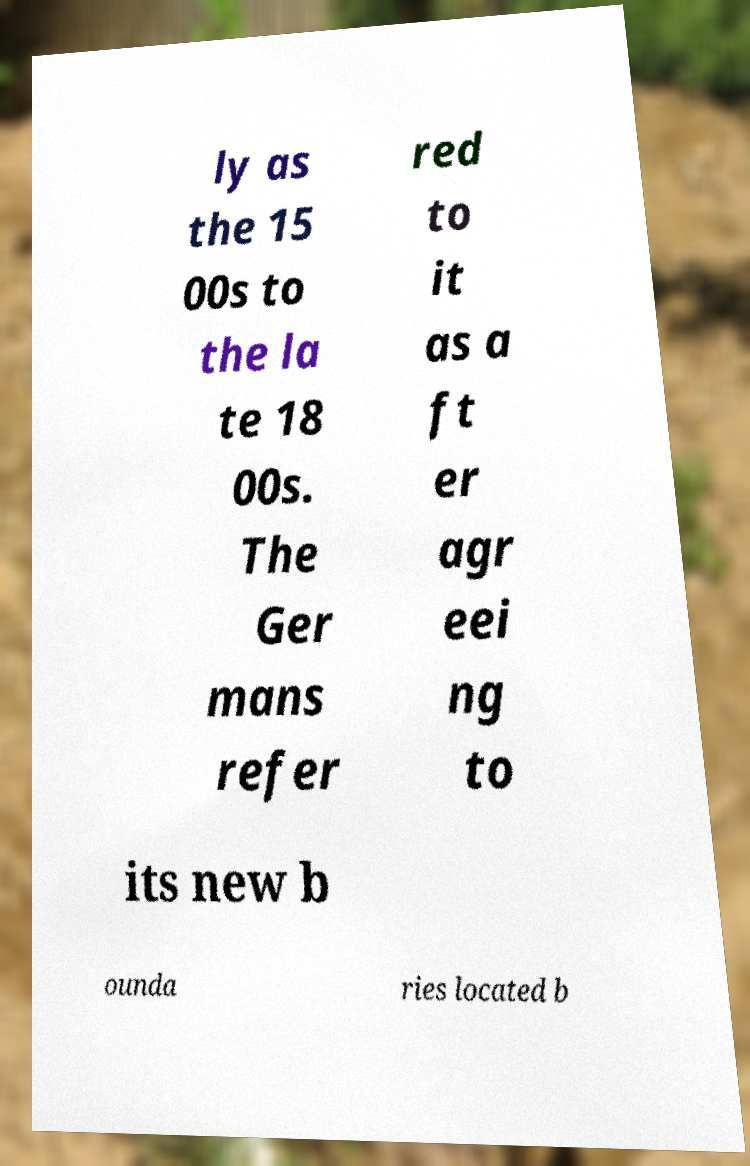There's text embedded in this image that I need extracted. Can you transcribe it verbatim? ly as the 15 00s to the la te 18 00s. The Ger mans refer red to it as a ft er agr eei ng to its new b ounda ries located b 